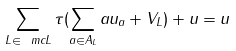<formula> <loc_0><loc_0><loc_500><loc_500>\sum _ { L \in \ m c { L } } \tau ( \sum _ { a \in A _ { L } } a u _ { a } + V _ { L } ) + u = u</formula> 